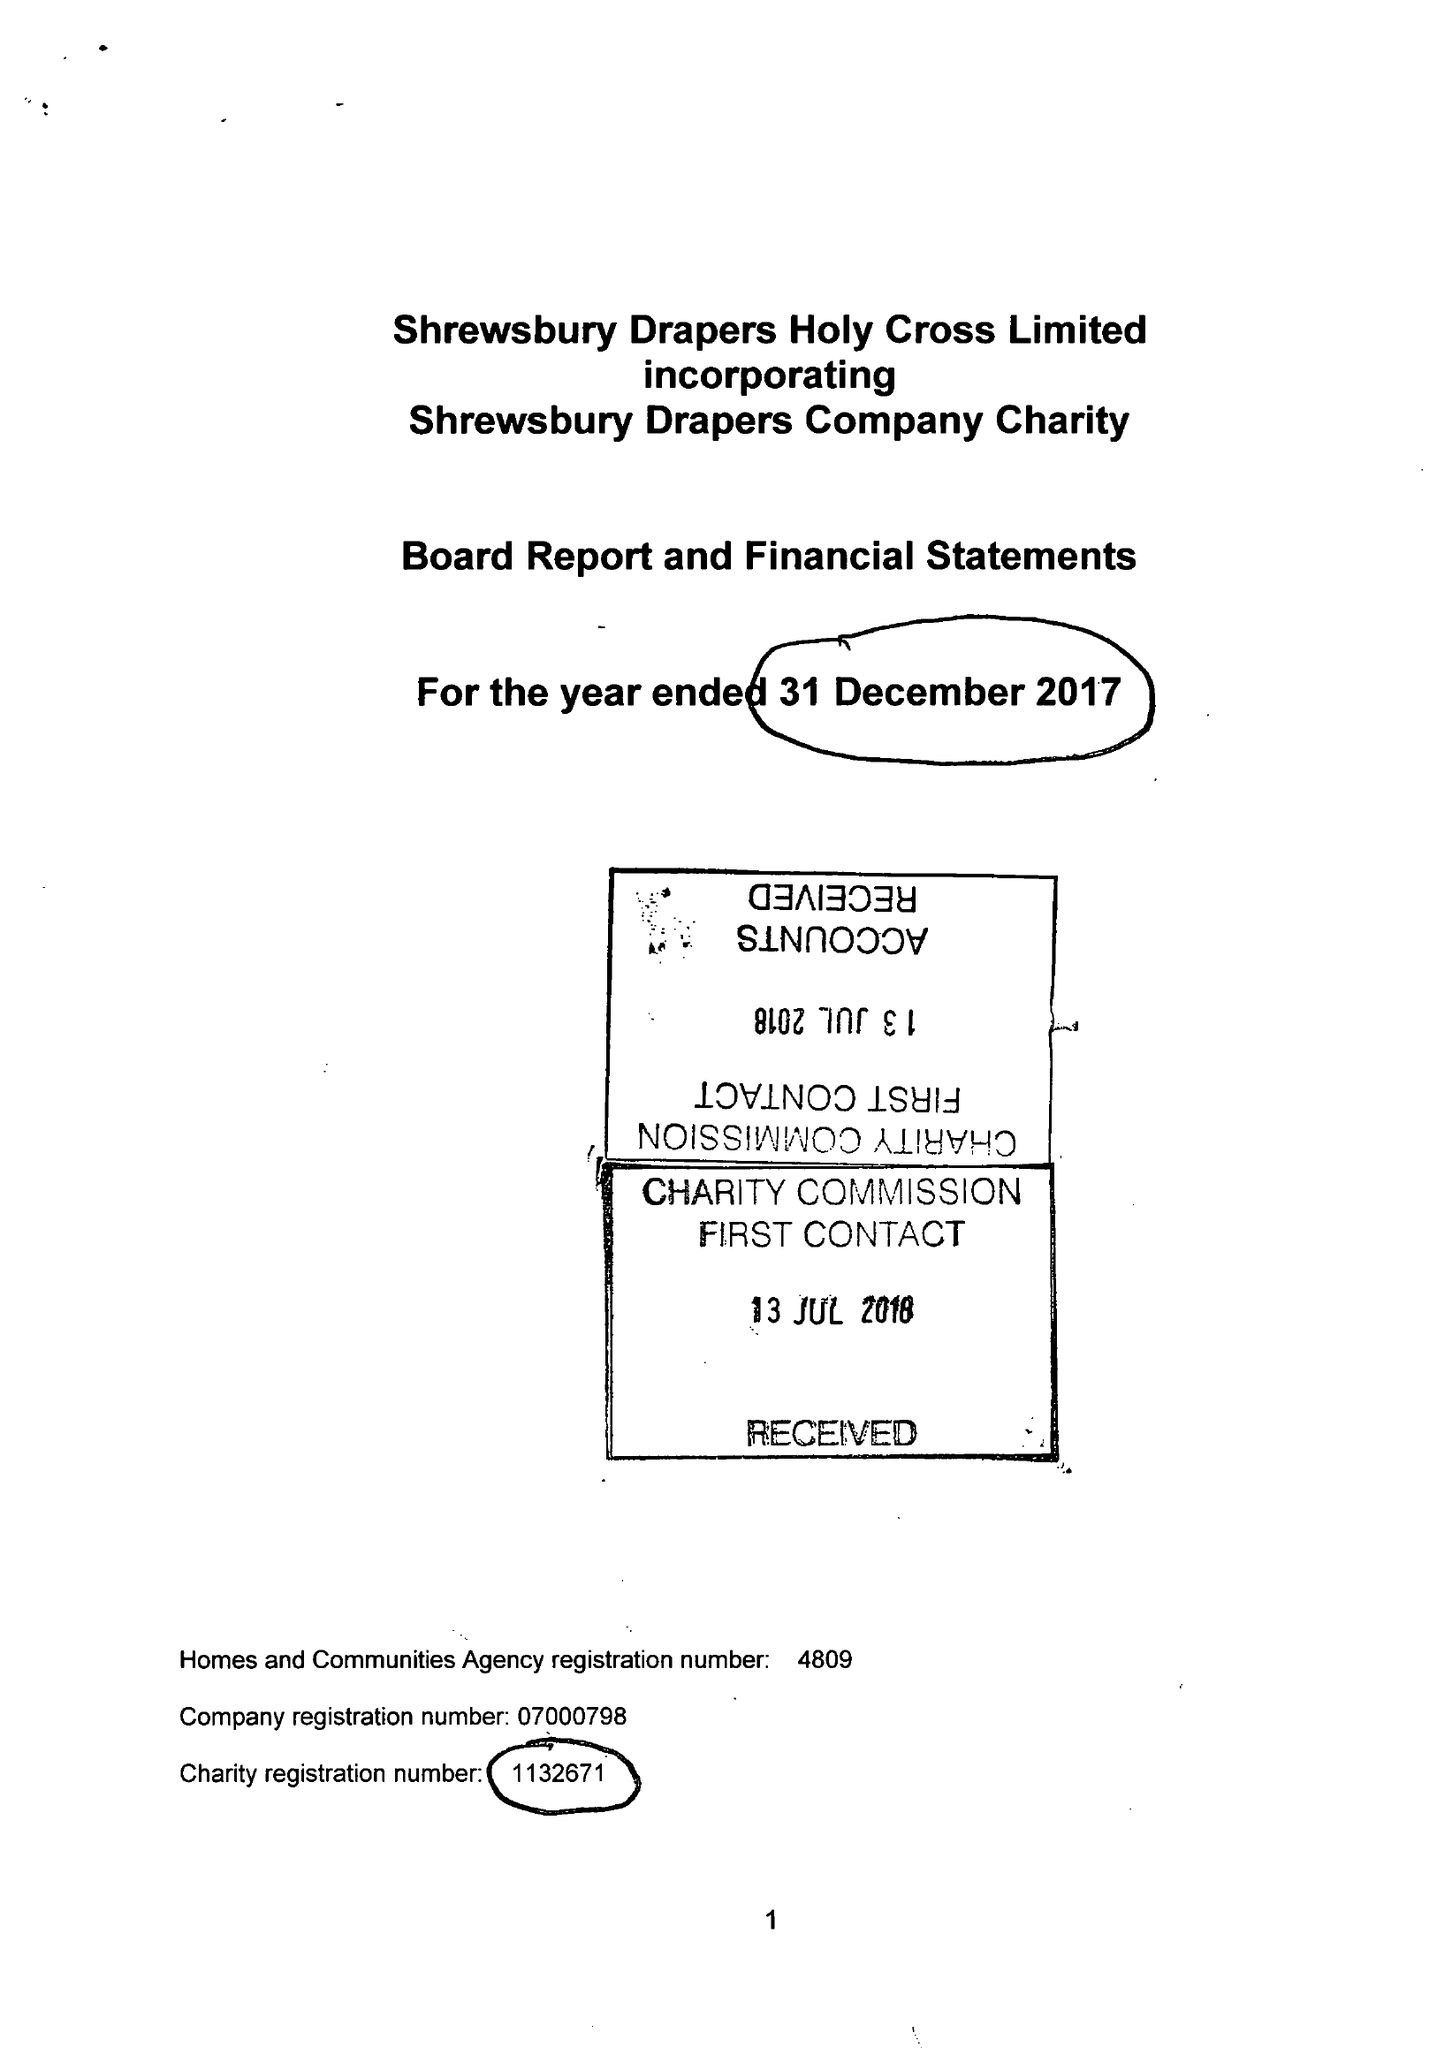What is the value for the income_annually_in_british_pounds?
Answer the question using a single word or phrase. 257874.00 